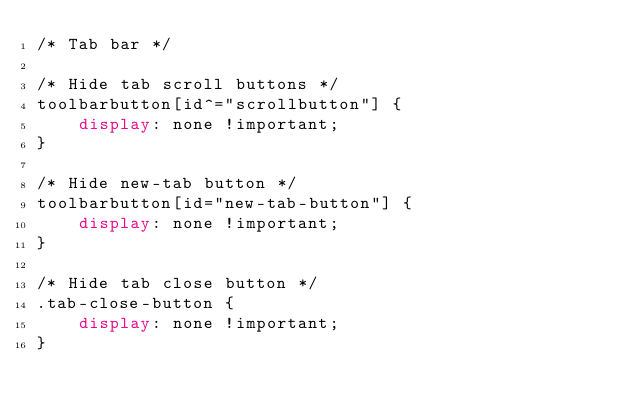<code> <loc_0><loc_0><loc_500><loc_500><_CSS_>/* Tab bar */

/* Hide tab scroll buttons */
toolbarbutton[id^="scrollbutton"] {
	display: none !important;
}

/* Hide new-tab button */
toolbarbutton[id="new-tab-button"] {
	display: none !important;
}

/* Hide tab close button */
.tab-close-button {
	display: none !important;
}
</code> 